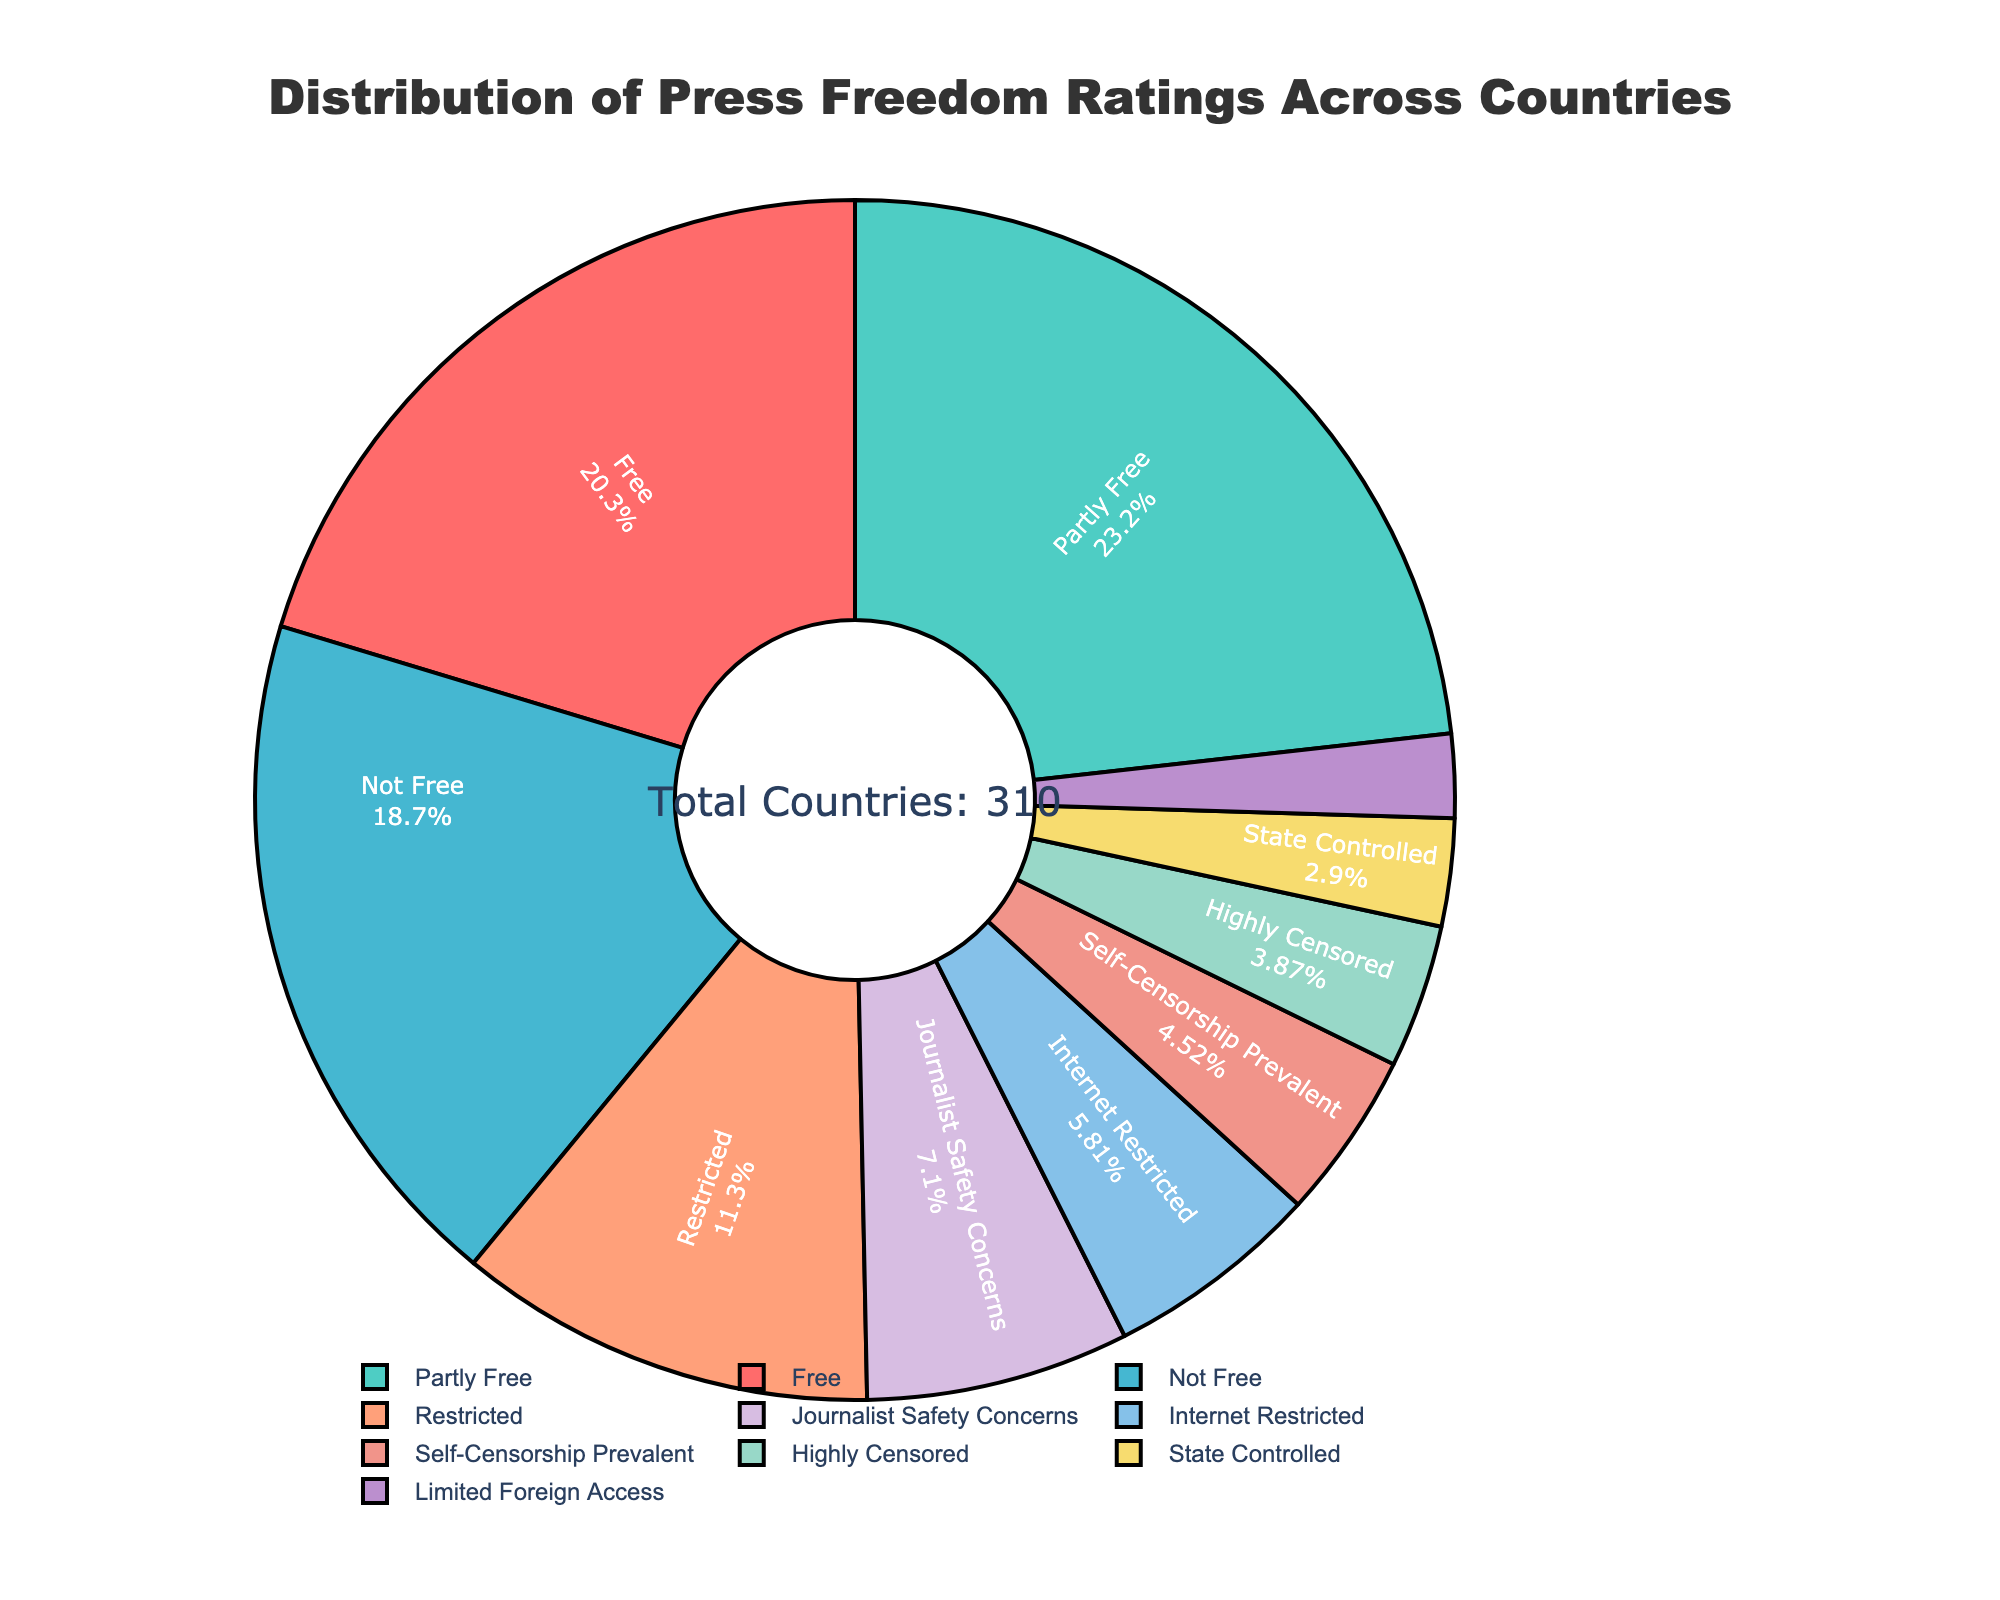What percentage of countries have a press freedom rating that is either "Free" or "Partly Free"? The labels indicate that there are 63 countries rated "Free" and 72 rated "Partly Free." Adding these together gives 135 countries. The total number of countries is 230 (the sum of all categories). To find the percentage, divide 135 by 230 and multiply by 100. (135 / 230) * 100 ≈ 58.70%
Answer: 58.70% Which press freedom rating category has the fewest countries? The figure shows the "State Controlled" category with the fewest countries, at 9. By checking all other categories, no label has a lower number than 9.
Answer: State Controlled How many more countries have a "Partly Free" rating compared to those with "Internet Restricted"? According to the labels, "Partly Free" has 72 countries, and "Internet Restricted" has 18. Subtracting the smaller from the larger (72 - 18) equals 54.
Answer: 54 What is the total number of countries with either "Self-Censorship Prevalent" or "Journalist Safety Concerns" ratings? The figure shows 14 countries for "Self-Censorship Prevalent" and 22 for "Journalist Safety Concerns." Adding these together gives 36 countries.
Answer: 36 Which categories account for more than 10% of the total number of countries, and what are their percentages? The total number of countries is 230. We calculate the percentage for each category by dividing the number of countries in that category by 230 and then multiplying by 100. The "Free" category has (63/230) * 100 ≈ 27.39%, and the "Partly Free" category has (72/230) * 100 ≈ 31.30%. Both percentages exceed 10%.
Answer: Free: 27.39% and Partly Free: 31.30% What is the combined percentage of countries with a "Restricted" or "Highly Censored" rating? "Restricted" has 35 countries, and "Highly Censored" has 12. Their combined total is 47. The percentage is (47 / 230) * 100. Therefore, (47 / 230) * 100 ≈ 20.43%.
Answer: 20.43% Compare the number of countries with "Not Free" and "Restricted" ratings. Which rating has more countries, and by how many? The "Not Free" category has 58 countries, while the "Restricted" category has 35. The difference is 58 - 35, which equals 23. The "Not Free" rating has more countries by 23.
Answer: Not Free by 23 What percentage of countries have neither "Free" nor "Partly Free" press freedom ratings? The total number of countries is 230. The sum of countries with "Free" is 63, and "Partly Free" is 72. Together, they equal 135. Subtracting this from the total gives 95 countries with neither "Free" nor "Partly Free" ratings. The percentage is (95 / 230) * 100, which is approximately 41.30%.
Answer: 41.30% What is the visual distinction of the "Highly Censored" category in the figure? The "Highly Censored" category is visually represented by its distinct pie slice color. It's labeled with its percentage and the number of countries, standing out in the pie chart.
Answer: Distinct color and label 